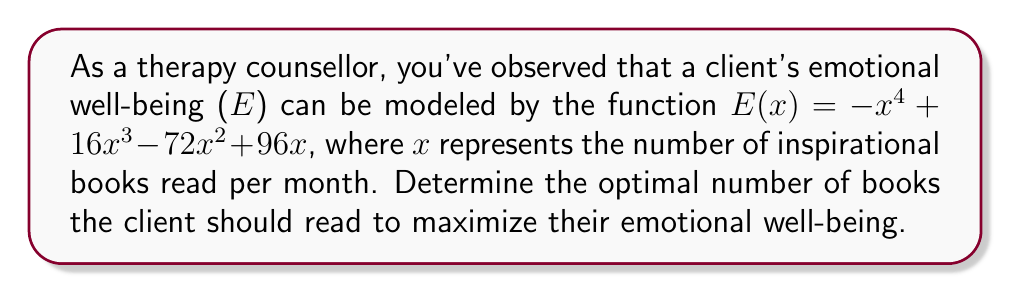Teach me how to tackle this problem. To find the optimal number of books, we need to determine the maximum point of the function $E(x)$. This can be done by following these steps:

1) Find the derivative of $E(x)$:
   $E'(x) = -4x^3 + 48x^2 - 144x + 96$

2) Set the derivative equal to zero and solve for x:
   $-4x^3 + 48x^2 - 144x + 96 = 0$
   $-4(x^3 - 12x^2 + 36x - 24) = 0$
   $-4(x - 2)(x^2 - 10x + 12) = 0$
   $-4(x - 2)(x - 6)(x - 4) = 0$

   The solutions are x = 2, 4, and 6.

3) Evaluate the second derivative at each critical point to determine the nature of the extrema:
   $E''(x) = -12x^2 + 96x - 144$
   
   At x = 2: $E''(2) = 48 > 0$, so this is a local minimum.
   At x = 4: $E''(4) = -48 < 0$, so this is a local maximum.
   At x = 6: $E''(6) = 48 > 0$, so this is a local minimum.

4) Therefore, the maximum emotional well-being occurs when x = 4.
Answer: 4 books per month 